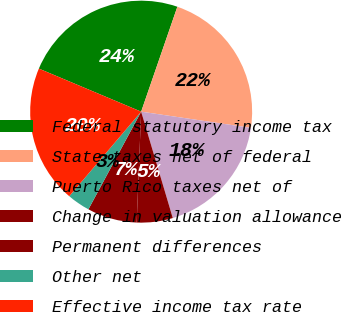Convert chart. <chart><loc_0><loc_0><loc_500><loc_500><pie_chart><fcel>Federal statutory income tax<fcel>State taxes net of federal<fcel>Puerto Rico taxes net of<fcel>Change in valuation allowance<fcel>Permanent differences<fcel>Other net<fcel>Effective income tax rate<nl><fcel>23.95%<fcel>22.04%<fcel>18.07%<fcel>5.24%<fcel>7.24%<fcel>3.33%<fcel>20.13%<nl></chart> 